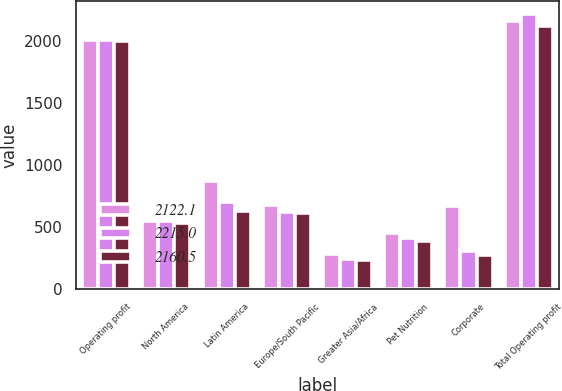Convert chart. <chart><loc_0><loc_0><loc_500><loc_500><stacked_bar_chart><ecel><fcel>Operating profit<fcel>North America<fcel>Latin America<fcel>Europe/South Pacific<fcel>Greater Asia/Africa<fcel>Pet Nutrition<fcel>Corporate<fcel>Total Operating profit<nl><fcel>2122.1<fcel>2006<fcel>550.1<fcel>872.9<fcel>681.2<fcel>278.7<fcel>447.9<fcel>670.3<fcel>2160.5<nl><fcel>2215<fcel>2005<fcel>545.7<fcel>698<fcel>619.8<fcel>245.5<fcel>412.8<fcel>306.8<fcel>2215<nl><fcel>2160.5<fcel>2004<fcel>530.1<fcel>627.7<fcel>611.5<fcel>237.6<fcel>389.7<fcel>274.5<fcel>2122.1<nl></chart> 